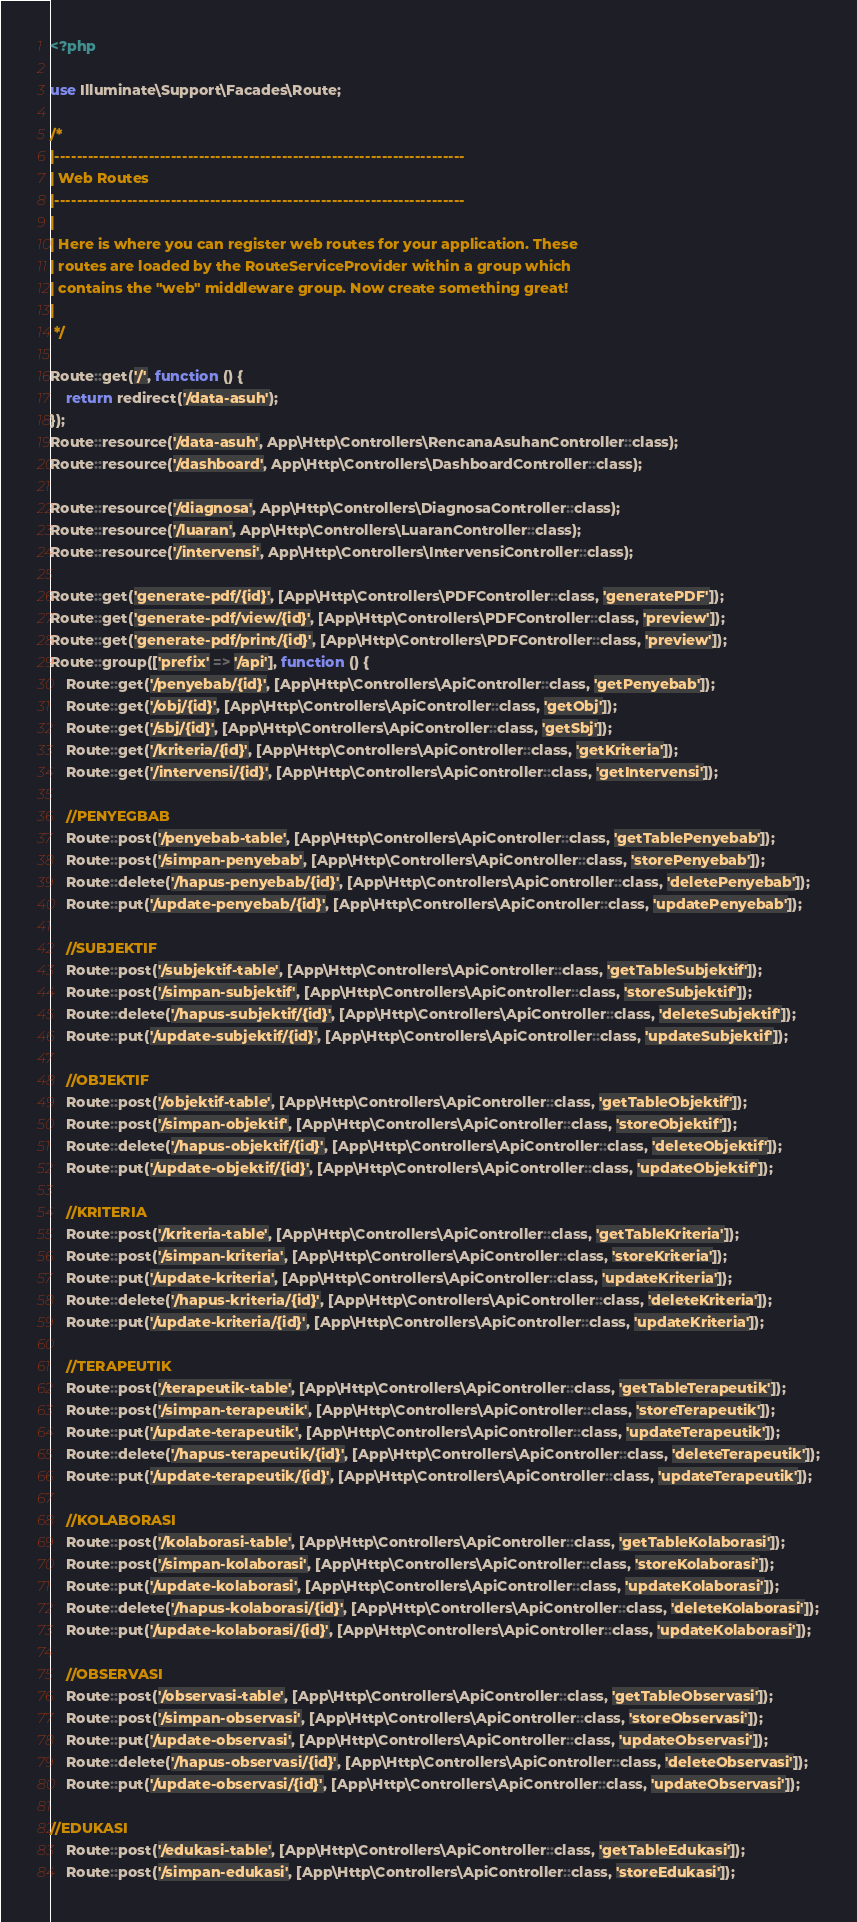Convert code to text. <code><loc_0><loc_0><loc_500><loc_500><_PHP_><?php

use Illuminate\Support\Facades\Route;

/*
|--------------------------------------------------------------------------
| Web Routes
|--------------------------------------------------------------------------
|
| Here is where you can register web routes for your application. These
| routes are loaded by the RouteServiceProvider within a group which
| contains the "web" middleware group. Now create something great!
|
 */

Route::get('/', function () {
    return redirect('/data-asuh');
});
Route::resource('/data-asuh', App\Http\Controllers\RencanaAsuhanController::class);
Route::resource('/dashboard', App\Http\Controllers\DashboardController::class);

Route::resource('/diagnosa', App\Http\Controllers\DiagnosaController::class);
Route::resource('/luaran', App\Http\Controllers\LuaranController::class);
Route::resource('/intervensi', App\Http\Controllers\IntervensiController::class);

Route::get('generate-pdf/{id}', [App\Http\Controllers\PDFController::class, 'generatePDF']);
Route::get('generate-pdf/view/{id}', [App\Http\Controllers\PDFController::class, 'preview']);
Route::get('generate-pdf/print/{id}', [App\Http\Controllers\PDFController::class, 'preview']);
Route::group(['prefix' => '/api'], function () {
    Route::get('/penyebab/{id}', [App\Http\Controllers\ApiController::class, 'getPenyebab']);
    Route::get('/obj/{id}', [App\Http\Controllers\ApiController::class, 'getObj']);
    Route::get('/sbj/{id}', [App\Http\Controllers\ApiController::class, 'getSbj']);
    Route::get('/kriteria/{id}', [App\Http\Controllers\ApiController::class, 'getKriteria']);
    Route::get('/intervensi/{id}', [App\Http\Controllers\ApiController::class, 'getIntervensi']);

    //PENYEGBAB
    Route::post('/penyebab-table', [App\Http\Controllers\ApiController::class, 'getTablePenyebab']);
    Route::post('/simpan-penyebab', [App\Http\Controllers\ApiController::class, 'storePenyebab']);
    Route::delete('/hapus-penyebab/{id}', [App\Http\Controllers\ApiController::class, 'deletePenyebab']);
    Route::put('/update-penyebab/{id}', [App\Http\Controllers\ApiController::class, 'updatePenyebab']);

    //SUBJEKTIF
    Route::post('/subjektif-table', [App\Http\Controllers\ApiController::class, 'getTableSubjektif']);
    Route::post('/simpan-subjektif', [App\Http\Controllers\ApiController::class, 'storeSubjektif']);
    Route::delete('/hapus-subjektif/{id}', [App\Http\Controllers\ApiController::class, 'deleteSubjektif']);
    Route::put('/update-subjektif/{id}', [App\Http\Controllers\ApiController::class, 'updateSubjektif']);

    //OBJEKTIF
    Route::post('/objektif-table', [App\Http\Controllers\ApiController::class, 'getTableObjektif']);
    Route::post('/simpan-objektif', [App\Http\Controllers\ApiController::class, 'storeObjektif']);
    Route::delete('/hapus-objektif/{id}', [App\Http\Controllers\ApiController::class, 'deleteObjektif']);
    Route::put('/update-objektif/{id}', [App\Http\Controllers\ApiController::class, 'updateObjektif']);

    //KRITERIA
    Route::post('/kriteria-table', [App\Http\Controllers\ApiController::class, 'getTableKriteria']);
    Route::post('/simpan-kriteria', [App\Http\Controllers\ApiController::class, 'storeKriteria']);
    Route::put('/update-kriteria', [App\Http\Controllers\ApiController::class, 'updateKriteria']);
    Route::delete('/hapus-kriteria/{id}', [App\Http\Controllers\ApiController::class, 'deleteKriteria']);
    Route::put('/update-kriteria/{id}', [App\Http\Controllers\ApiController::class, 'updateKriteria']);

    //TERAPEUTIK
    Route::post('/terapeutik-table', [App\Http\Controllers\ApiController::class, 'getTableTerapeutik']);
    Route::post('/simpan-terapeutik', [App\Http\Controllers\ApiController::class, 'storeTerapeutik']);
    Route::put('/update-terapeutik', [App\Http\Controllers\ApiController::class, 'updateTerapeutik']);
    Route::delete('/hapus-terapeutik/{id}', [App\Http\Controllers\ApiController::class, 'deleteTerapeutik']);
    Route::put('/update-terapeutik/{id}', [App\Http\Controllers\ApiController::class, 'updateTerapeutik']);

    //KOLABORASI
    Route::post('/kolaborasi-table', [App\Http\Controllers\ApiController::class, 'getTableKolaborasi']);
    Route::post('/simpan-kolaborasi', [App\Http\Controllers\ApiController::class, 'storeKolaborasi']);
    Route::put('/update-kolaborasi', [App\Http\Controllers\ApiController::class, 'updateKolaborasi']);
    Route::delete('/hapus-kolaborasi/{id}', [App\Http\Controllers\ApiController::class, 'deleteKolaborasi']);
    Route::put('/update-kolaborasi/{id}', [App\Http\Controllers\ApiController::class, 'updateKolaborasi']);

    //OBSERVASI
    Route::post('/observasi-table', [App\Http\Controllers\ApiController::class, 'getTableObservasi']);
    Route::post('/simpan-observasi', [App\Http\Controllers\ApiController::class, 'storeObservasi']);
    Route::put('/update-observasi', [App\Http\Controllers\ApiController::class, 'updateObservasi']);
    Route::delete('/hapus-observasi/{id}', [App\Http\Controllers\ApiController::class, 'deleteObservasi']);
    Route::put('/update-observasi/{id}', [App\Http\Controllers\ApiController::class, 'updateObservasi']);

//EDUKASI
    Route::post('/edukasi-table', [App\Http\Controllers\ApiController::class, 'getTableEdukasi']);
    Route::post('/simpan-edukasi', [App\Http\Controllers\ApiController::class, 'storeEdukasi']);</code> 